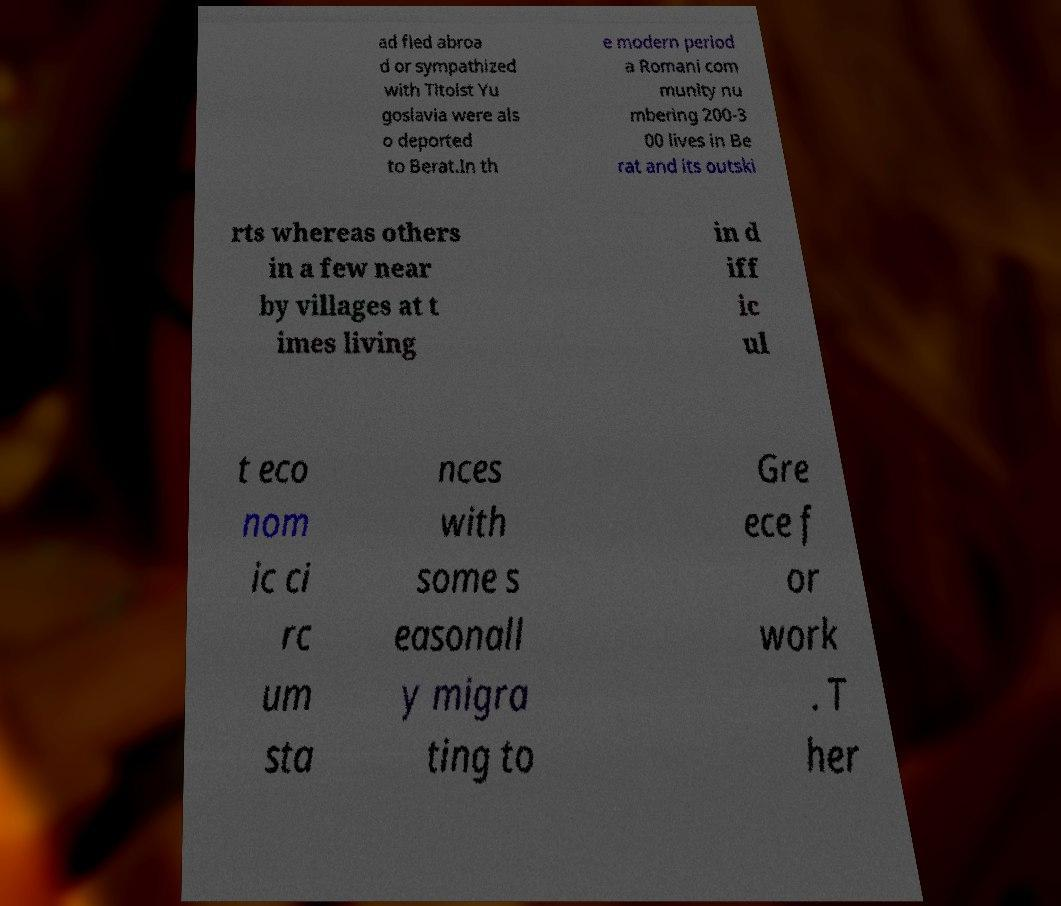Could you assist in decoding the text presented in this image and type it out clearly? ad fled abroa d or sympathized with Titoist Yu goslavia were als o deported to Berat.In th e modern period a Romani com munity nu mbering 200-3 00 lives in Be rat and its outski rts whereas others in a few near by villages at t imes living in d iff ic ul t eco nom ic ci rc um sta nces with some s easonall y migra ting to Gre ece f or work . T her 